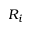<formula> <loc_0><loc_0><loc_500><loc_500>R _ { i }</formula> 